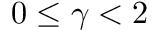Convert formula to latex. <formula><loc_0><loc_0><loc_500><loc_500>0 \leq \gamma < 2</formula> 